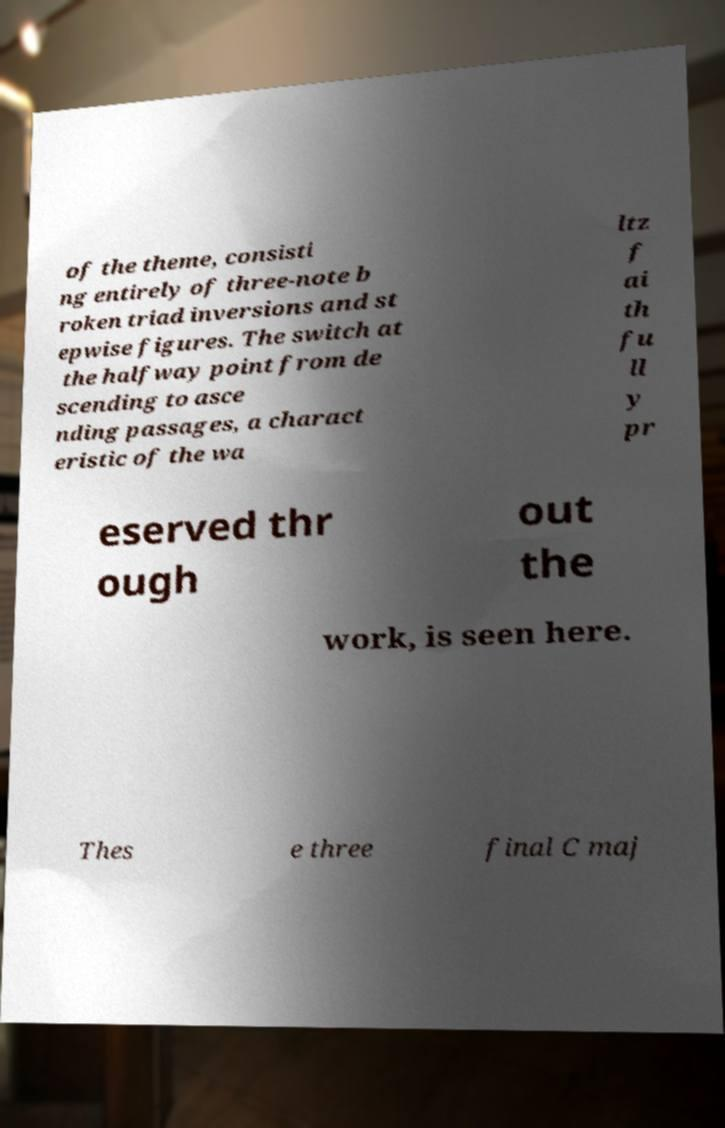What messages or text are displayed in this image? I need them in a readable, typed format. of the theme, consisti ng entirely of three-note b roken triad inversions and st epwise figures. The switch at the halfway point from de scending to asce nding passages, a charact eristic of the wa ltz f ai th fu ll y pr eserved thr ough out the work, is seen here. Thes e three final C maj 